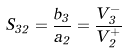Convert formula to latex. <formula><loc_0><loc_0><loc_500><loc_500>S _ { 3 2 } = \frac { b _ { 3 } } { a _ { 2 } } = \frac { V _ { 3 } ^ { - } } { V _ { 2 } ^ { + } }</formula> 